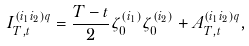<formula> <loc_0><loc_0><loc_500><loc_500>I _ { T , t } ^ { ( i _ { 1 } i _ { 2 } ) q } = \frac { T - t } { 2 } \zeta _ { 0 } ^ { ( i _ { 1 } ) } \zeta _ { 0 } ^ { ( i _ { 2 } ) } + A _ { T , t } ^ { ( i _ { 1 } i _ { 2 } ) q } ,</formula> 